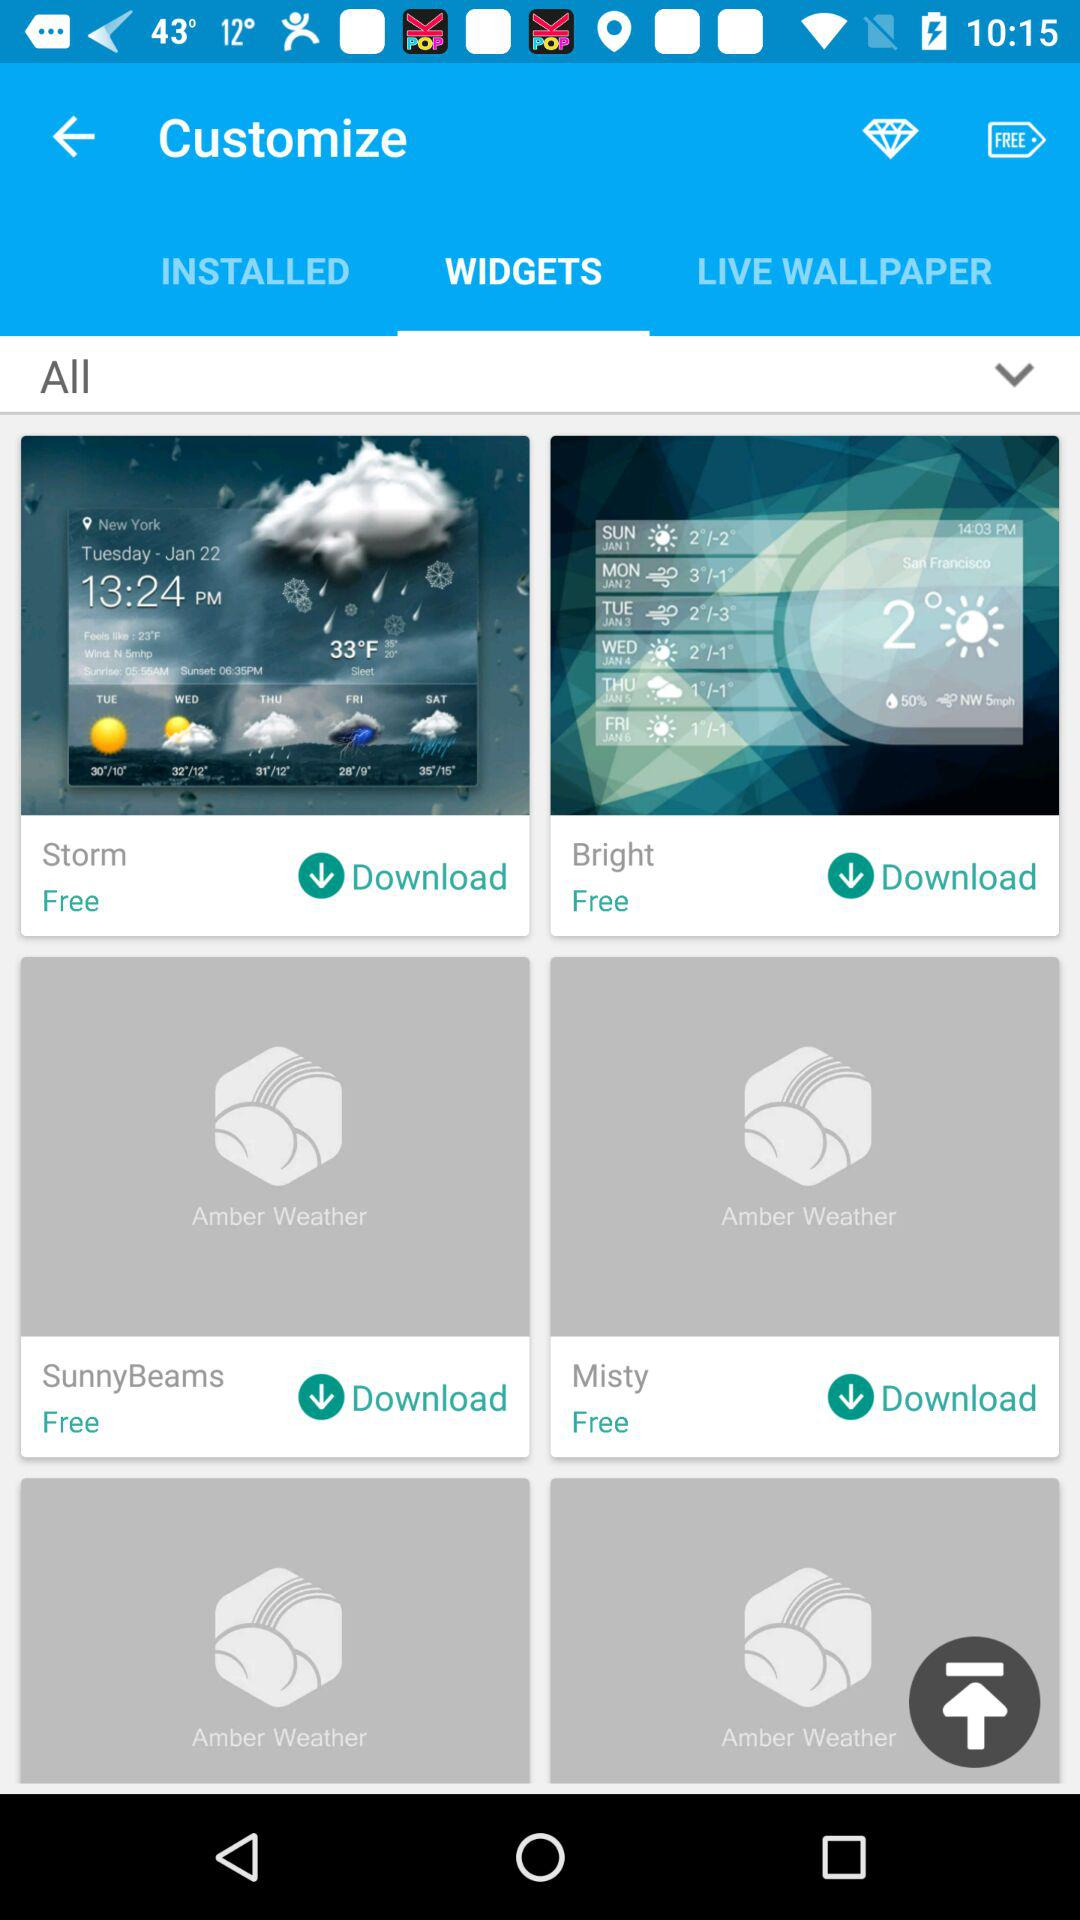How much do I have to pay to use Storm Widget? It's free to use Storm Widget. 